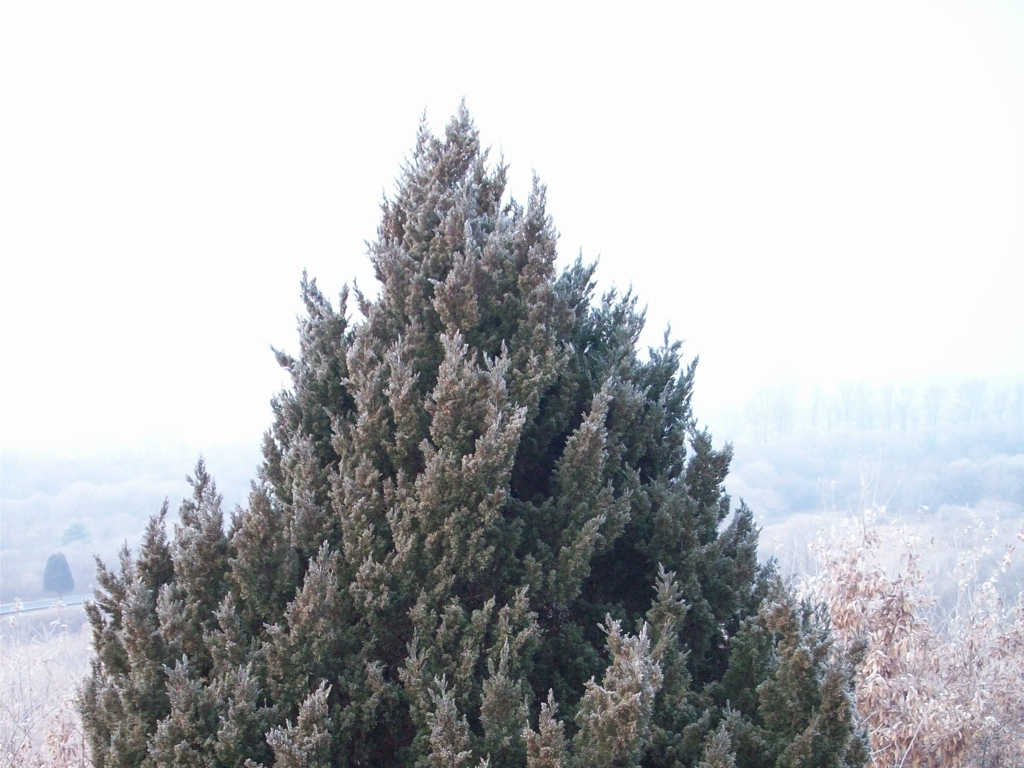What can be observed in this image?
A. lush green leaves
B. brown soil
C. thick fog
Answer with the option's letter from the given choices directly.
 A. 